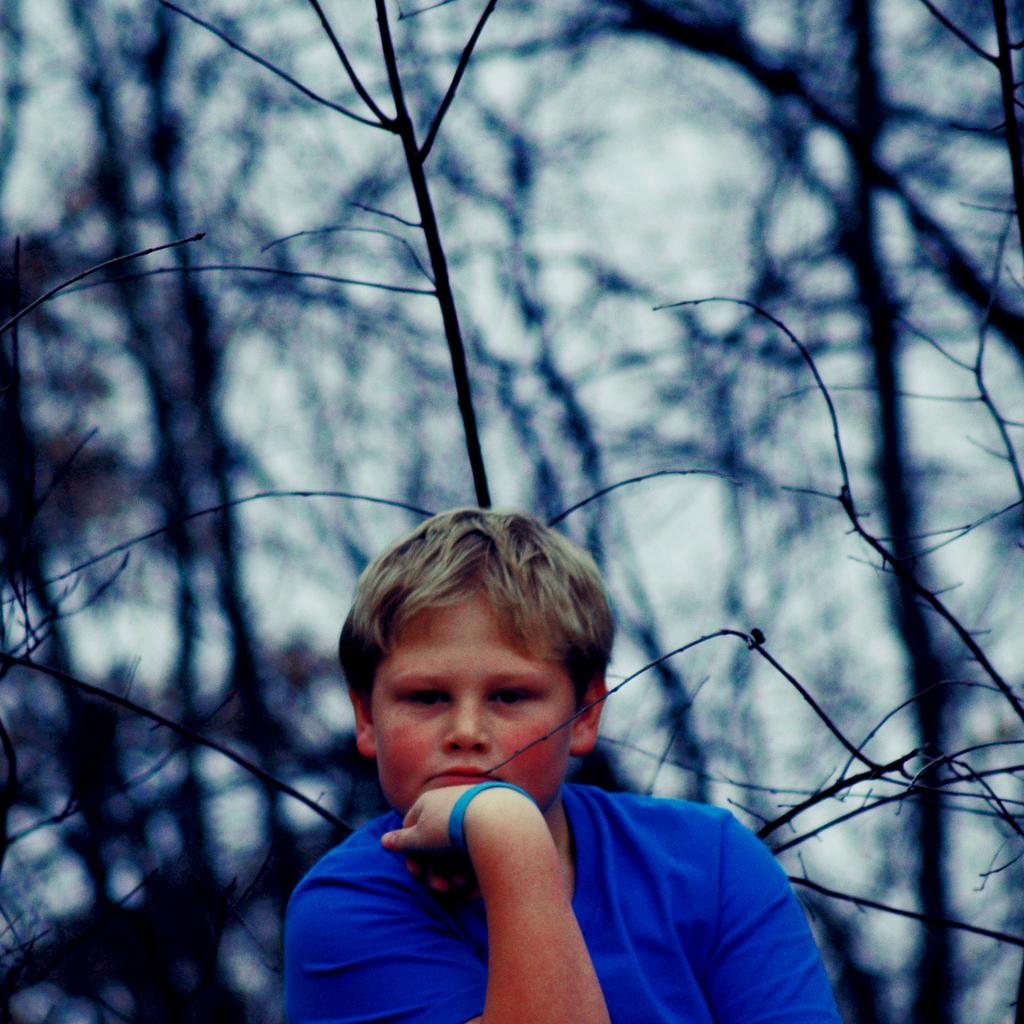Who or what is the main subject in the image? There is a person in the image. What is the person wearing? The person is wearing a blue T-shirt. Can you describe the background of the image? The background of the image is blurred. What type of vegetation can be seen in the background? Dry trees are visible in the background of the image. What riddle is the person trying to solve in the image? There is no riddle present in the image; it only features a person wearing a blue T-shirt with a blurred background and dry trees in the distance. 